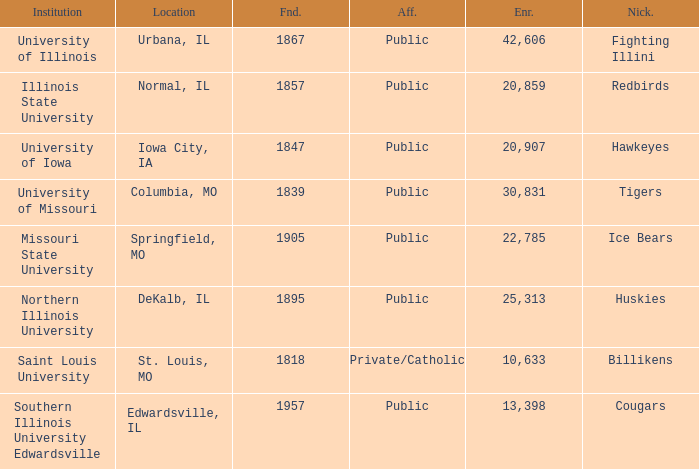What is the average enrollment of the Redbirds' school? 20859.0. 